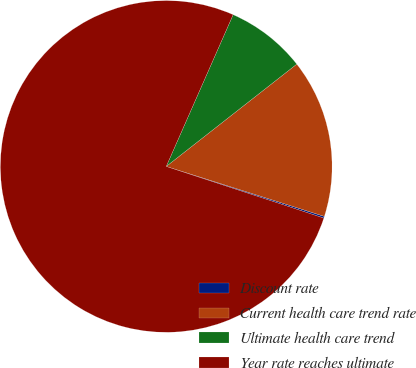<chart> <loc_0><loc_0><loc_500><loc_500><pie_chart><fcel>Discount rate<fcel>Current health care trend rate<fcel>Ultimate health care trend<fcel>Year rate reaches ultimate<nl><fcel>0.17%<fcel>15.45%<fcel>7.81%<fcel>76.56%<nl></chart> 